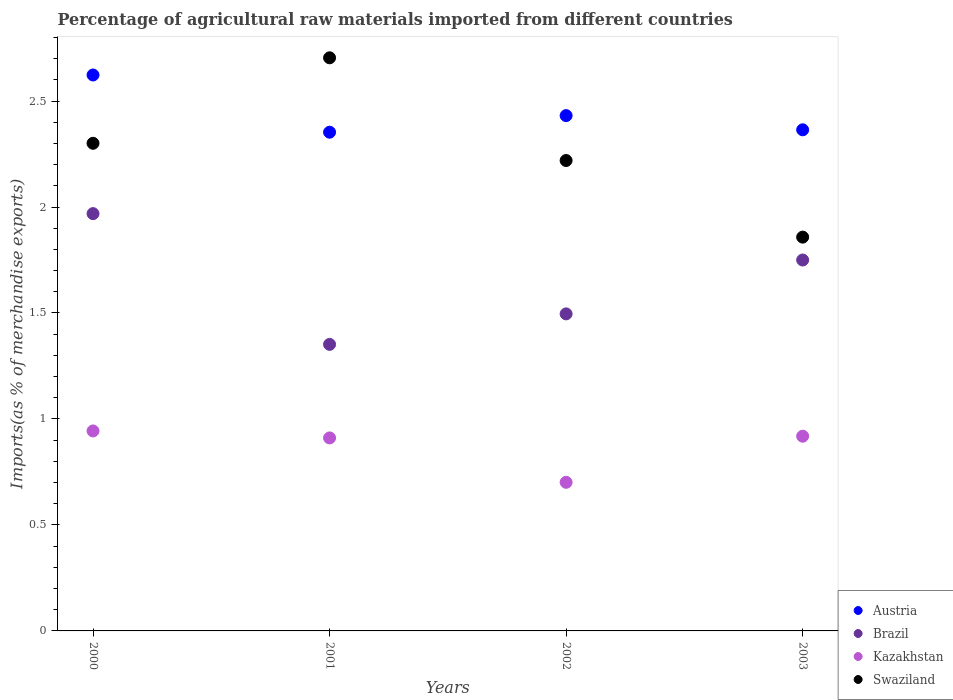Is the number of dotlines equal to the number of legend labels?
Give a very brief answer. Yes. What is the percentage of imports to different countries in Swaziland in 2001?
Keep it short and to the point. 2.7. Across all years, what is the maximum percentage of imports to different countries in Brazil?
Give a very brief answer. 1.97. Across all years, what is the minimum percentage of imports to different countries in Swaziland?
Offer a very short reply. 1.86. What is the total percentage of imports to different countries in Austria in the graph?
Offer a very short reply. 9.77. What is the difference between the percentage of imports to different countries in Kazakhstan in 2000 and that in 2001?
Your answer should be very brief. 0.03. What is the difference between the percentage of imports to different countries in Swaziland in 2003 and the percentage of imports to different countries in Brazil in 2001?
Ensure brevity in your answer.  0.51. What is the average percentage of imports to different countries in Brazil per year?
Keep it short and to the point. 1.64. In the year 2000, what is the difference between the percentage of imports to different countries in Kazakhstan and percentage of imports to different countries in Brazil?
Offer a very short reply. -1.03. What is the ratio of the percentage of imports to different countries in Brazil in 2002 to that in 2003?
Your response must be concise. 0.85. What is the difference between the highest and the second highest percentage of imports to different countries in Swaziland?
Keep it short and to the point. 0.4. What is the difference between the highest and the lowest percentage of imports to different countries in Brazil?
Keep it short and to the point. 0.62. Is it the case that in every year, the sum of the percentage of imports to different countries in Kazakhstan and percentage of imports to different countries in Brazil  is greater than the sum of percentage of imports to different countries in Austria and percentage of imports to different countries in Swaziland?
Provide a short and direct response. No. Does the percentage of imports to different countries in Austria monotonically increase over the years?
Ensure brevity in your answer.  No. Are the values on the major ticks of Y-axis written in scientific E-notation?
Your answer should be compact. No. Where does the legend appear in the graph?
Your answer should be compact. Bottom right. What is the title of the graph?
Keep it short and to the point. Percentage of agricultural raw materials imported from different countries. What is the label or title of the Y-axis?
Ensure brevity in your answer.  Imports(as % of merchandise exports). What is the Imports(as % of merchandise exports) of Austria in 2000?
Provide a succinct answer. 2.62. What is the Imports(as % of merchandise exports) in Brazil in 2000?
Provide a succinct answer. 1.97. What is the Imports(as % of merchandise exports) of Kazakhstan in 2000?
Provide a short and direct response. 0.94. What is the Imports(as % of merchandise exports) of Swaziland in 2000?
Your answer should be very brief. 2.3. What is the Imports(as % of merchandise exports) of Austria in 2001?
Keep it short and to the point. 2.35. What is the Imports(as % of merchandise exports) of Brazil in 2001?
Provide a short and direct response. 1.35. What is the Imports(as % of merchandise exports) of Kazakhstan in 2001?
Provide a succinct answer. 0.91. What is the Imports(as % of merchandise exports) in Swaziland in 2001?
Ensure brevity in your answer.  2.7. What is the Imports(as % of merchandise exports) in Austria in 2002?
Your answer should be compact. 2.43. What is the Imports(as % of merchandise exports) of Brazil in 2002?
Your answer should be very brief. 1.5. What is the Imports(as % of merchandise exports) in Kazakhstan in 2002?
Offer a terse response. 0.7. What is the Imports(as % of merchandise exports) in Swaziland in 2002?
Offer a very short reply. 2.22. What is the Imports(as % of merchandise exports) in Austria in 2003?
Give a very brief answer. 2.36. What is the Imports(as % of merchandise exports) of Brazil in 2003?
Your response must be concise. 1.75. What is the Imports(as % of merchandise exports) in Kazakhstan in 2003?
Offer a very short reply. 0.92. What is the Imports(as % of merchandise exports) in Swaziland in 2003?
Keep it short and to the point. 1.86. Across all years, what is the maximum Imports(as % of merchandise exports) of Austria?
Keep it short and to the point. 2.62. Across all years, what is the maximum Imports(as % of merchandise exports) of Brazil?
Your response must be concise. 1.97. Across all years, what is the maximum Imports(as % of merchandise exports) of Kazakhstan?
Offer a terse response. 0.94. Across all years, what is the maximum Imports(as % of merchandise exports) of Swaziland?
Ensure brevity in your answer.  2.7. Across all years, what is the minimum Imports(as % of merchandise exports) of Austria?
Offer a terse response. 2.35. Across all years, what is the minimum Imports(as % of merchandise exports) of Brazil?
Make the answer very short. 1.35. Across all years, what is the minimum Imports(as % of merchandise exports) of Kazakhstan?
Keep it short and to the point. 0.7. Across all years, what is the minimum Imports(as % of merchandise exports) of Swaziland?
Your answer should be compact. 1.86. What is the total Imports(as % of merchandise exports) of Austria in the graph?
Offer a terse response. 9.77. What is the total Imports(as % of merchandise exports) in Brazil in the graph?
Keep it short and to the point. 6.57. What is the total Imports(as % of merchandise exports) of Kazakhstan in the graph?
Offer a very short reply. 3.47. What is the total Imports(as % of merchandise exports) of Swaziland in the graph?
Keep it short and to the point. 9.08. What is the difference between the Imports(as % of merchandise exports) in Austria in 2000 and that in 2001?
Your response must be concise. 0.27. What is the difference between the Imports(as % of merchandise exports) in Brazil in 2000 and that in 2001?
Your answer should be very brief. 0.62. What is the difference between the Imports(as % of merchandise exports) in Kazakhstan in 2000 and that in 2001?
Provide a succinct answer. 0.03. What is the difference between the Imports(as % of merchandise exports) of Swaziland in 2000 and that in 2001?
Offer a terse response. -0.4. What is the difference between the Imports(as % of merchandise exports) in Austria in 2000 and that in 2002?
Offer a terse response. 0.19. What is the difference between the Imports(as % of merchandise exports) of Brazil in 2000 and that in 2002?
Your answer should be compact. 0.47. What is the difference between the Imports(as % of merchandise exports) of Kazakhstan in 2000 and that in 2002?
Offer a very short reply. 0.24. What is the difference between the Imports(as % of merchandise exports) in Swaziland in 2000 and that in 2002?
Your answer should be compact. 0.08. What is the difference between the Imports(as % of merchandise exports) of Austria in 2000 and that in 2003?
Your answer should be very brief. 0.26. What is the difference between the Imports(as % of merchandise exports) in Brazil in 2000 and that in 2003?
Your response must be concise. 0.22. What is the difference between the Imports(as % of merchandise exports) in Kazakhstan in 2000 and that in 2003?
Make the answer very short. 0.02. What is the difference between the Imports(as % of merchandise exports) in Swaziland in 2000 and that in 2003?
Ensure brevity in your answer.  0.44. What is the difference between the Imports(as % of merchandise exports) of Austria in 2001 and that in 2002?
Offer a terse response. -0.08. What is the difference between the Imports(as % of merchandise exports) of Brazil in 2001 and that in 2002?
Your answer should be very brief. -0.14. What is the difference between the Imports(as % of merchandise exports) of Kazakhstan in 2001 and that in 2002?
Provide a short and direct response. 0.21. What is the difference between the Imports(as % of merchandise exports) in Swaziland in 2001 and that in 2002?
Give a very brief answer. 0.48. What is the difference between the Imports(as % of merchandise exports) of Austria in 2001 and that in 2003?
Your response must be concise. -0.01. What is the difference between the Imports(as % of merchandise exports) in Brazil in 2001 and that in 2003?
Give a very brief answer. -0.4. What is the difference between the Imports(as % of merchandise exports) of Kazakhstan in 2001 and that in 2003?
Provide a short and direct response. -0.01. What is the difference between the Imports(as % of merchandise exports) of Swaziland in 2001 and that in 2003?
Your response must be concise. 0.85. What is the difference between the Imports(as % of merchandise exports) of Austria in 2002 and that in 2003?
Give a very brief answer. 0.07. What is the difference between the Imports(as % of merchandise exports) of Brazil in 2002 and that in 2003?
Provide a short and direct response. -0.25. What is the difference between the Imports(as % of merchandise exports) in Kazakhstan in 2002 and that in 2003?
Your response must be concise. -0.22. What is the difference between the Imports(as % of merchandise exports) of Swaziland in 2002 and that in 2003?
Ensure brevity in your answer.  0.36. What is the difference between the Imports(as % of merchandise exports) of Austria in 2000 and the Imports(as % of merchandise exports) of Brazil in 2001?
Keep it short and to the point. 1.27. What is the difference between the Imports(as % of merchandise exports) of Austria in 2000 and the Imports(as % of merchandise exports) of Kazakhstan in 2001?
Ensure brevity in your answer.  1.71. What is the difference between the Imports(as % of merchandise exports) in Austria in 2000 and the Imports(as % of merchandise exports) in Swaziland in 2001?
Ensure brevity in your answer.  -0.08. What is the difference between the Imports(as % of merchandise exports) of Brazil in 2000 and the Imports(as % of merchandise exports) of Kazakhstan in 2001?
Offer a very short reply. 1.06. What is the difference between the Imports(as % of merchandise exports) in Brazil in 2000 and the Imports(as % of merchandise exports) in Swaziland in 2001?
Provide a succinct answer. -0.74. What is the difference between the Imports(as % of merchandise exports) of Kazakhstan in 2000 and the Imports(as % of merchandise exports) of Swaziland in 2001?
Provide a succinct answer. -1.76. What is the difference between the Imports(as % of merchandise exports) in Austria in 2000 and the Imports(as % of merchandise exports) in Brazil in 2002?
Provide a succinct answer. 1.13. What is the difference between the Imports(as % of merchandise exports) in Austria in 2000 and the Imports(as % of merchandise exports) in Kazakhstan in 2002?
Make the answer very short. 1.92. What is the difference between the Imports(as % of merchandise exports) in Austria in 2000 and the Imports(as % of merchandise exports) in Swaziland in 2002?
Ensure brevity in your answer.  0.4. What is the difference between the Imports(as % of merchandise exports) in Brazil in 2000 and the Imports(as % of merchandise exports) in Kazakhstan in 2002?
Keep it short and to the point. 1.27. What is the difference between the Imports(as % of merchandise exports) in Brazil in 2000 and the Imports(as % of merchandise exports) in Swaziland in 2002?
Your response must be concise. -0.25. What is the difference between the Imports(as % of merchandise exports) in Kazakhstan in 2000 and the Imports(as % of merchandise exports) in Swaziland in 2002?
Make the answer very short. -1.28. What is the difference between the Imports(as % of merchandise exports) of Austria in 2000 and the Imports(as % of merchandise exports) of Brazil in 2003?
Your answer should be very brief. 0.87. What is the difference between the Imports(as % of merchandise exports) of Austria in 2000 and the Imports(as % of merchandise exports) of Kazakhstan in 2003?
Your answer should be very brief. 1.7. What is the difference between the Imports(as % of merchandise exports) in Austria in 2000 and the Imports(as % of merchandise exports) in Swaziland in 2003?
Provide a succinct answer. 0.77. What is the difference between the Imports(as % of merchandise exports) of Brazil in 2000 and the Imports(as % of merchandise exports) of Kazakhstan in 2003?
Your answer should be very brief. 1.05. What is the difference between the Imports(as % of merchandise exports) in Brazil in 2000 and the Imports(as % of merchandise exports) in Swaziland in 2003?
Ensure brevity in your answer.  0.11. What is the difference between the Imports(as % of merchandise exports) in Kazakhstan in 2000 and the Imports(as % of merchandise exports) in Swaziland in 2003?
Your answer should be compact. -0.91. What is the difference between the Imports(as % of merchandise exports) in Austria in 2001 and the Imports(as % of merchandise exports) in Brazil in 2002?
Your answer should be compact. 0.86. What is the difference between the Imports(as % of merchandise exports) of Austria in 2001 and the Imports(as % of merchandise exports) of Kazakhstan in 2002?
Provide a succinct answer. 1.65. What is the difference between the Imports(as % of merchandise exports) of Austria in 2001 and the Imports(as % of merchandise exports) of Swaziland in 2002?
Your response must be concise. 0.13. What is the difference between the Imports(as % of merchandise exports) of Brazil in 2001 and the Imports(as % of merchandise exports) of Kazakhstan in 2002?
Your answer should be compact. 0.65. What is the difference between the Imports(as % of merchandise exports) in Brazil in 2001 and the Imports(as % of merchandise exports) in Swaziland in 2002?
Ensure brevity in your answer.  -0.87. What is the difference between the Imports(as % of merchandise exports) of Kazakhstan in 2001 and the Imports(as % of merchandise exports) of Swaziland in 2002?
Ensure brevity in your answer.  -1.31. What is the difference between the Imports(as % of merchandise exports) of Austria in 2001 and the Imports(as % of merchandise exports) of Brazil in 2003?
Your answer should be very brief. 0.6. What is the difference between the Imports(as % of merchandise exports) in Austria in 2001 and the Imports(as % of merchandise exports) in Kazakhstan in 2003?
Give a very brief answer. 1.43. What is the difference between the Imports(as % of merchandise exports) of Austria in 2001 and the Imports(as % of merchandise exports) of Swaziland in 2003?
Provide a short and direct response. 0.49. What is the difference between the Imports(as % of merchandise exports) of Brazil in 2001 and the Imports(as % of merchandise exports) of Kazakhstan in 2003?
Make the answer very short. 0.43. What is the difference between the Imports(as % of merchandise exports) of Brazil in 2001 and the Imports(as % of merchandise exports) of Swaziland in 2003?
Ensure brevity in your answer.  -0.51. What is the difference between the Imports(as % of merchandise exports) of Kazakhstan in 2001 and the Imports(as % of merchandise exports) of Swaziland in 2003?
Your answer should be compact. -0.95. What is the difference between the Imports(as % of merchandise exports) in Austria in 2002 and the Imports(as % of merchandise exports) in Brazil in 2003?
Your answer should be very brief. 0.68. What is the difference between the Imports(as % of merchandise exports) in Austria in 2002 and the Imports(as % of merchandise exports) in Kazakhstan in 2003?
Offer a very short reply. 1.51. What is the difference between the Imports(as % of merchandise exports) of Austria in 2002 and the Imports(as % of merchandise exports) of Swaziland in 2003?
Ensure brevity in your answer.  0.57. What is the difference between the Imports(as % of merchandise exports) in Brazil in 2002 and the Imports(as % of merchandise exports) in Kazakhstan in 2003?
Offer a terse response. 0.58. What is the difference between the Imports(as % of merchandise exports) of Brazil in 2002 and the Imports(as % of merchandise exports) of Swaziland in 2003?
Offer a terse response. -0.36. What is the difference between the Imports(as % of merchandise exports) of Kazakhstan in 2002 and the Imports(as % of merchandise exports) of Swaziland in 2003?
Your answer should be compact. -1.16. What is the average Imports(as % of merchandise exports) of Austria per year?
Your answer should be compact. 2.44. What is the average Imports(as % of merchandise exports) of Brazil per year?
Provide a short and direct response. 1.64. What is the average Imports(as % of merchandise exports) of Kazakhstan per year?
Offer a very short reply. 0.87. What is the average Imports(as % of merchandise exports) of Swaziland per year?
Provide a succinct answer. 2.27. In the year 2000, what is the difference between the Imports(as % of merchandise exports) in Austria and Imports(as % of merchandise exports) in Brazil?
Provide a short and direct response. 0.65. In the year 2000, what is the difference between the Imports(as % of merchandise exports) of Austria and Imports(as % of merchandise exports) of Kazakhstan?
Give a very brief answer. 1.68. In the year 2000, what is the difference between the Imports(as % of merchandise exports) in Austria and Imports(as % of merchandise exports) in Swaziland?
Your response must be concise. 0.32. In the year 2000, what is the difference between the Imports(as % of merchandise exports) in Brazil and Imports(as % of merchandise exports) in Kazakhstan?
Offer a terse response. 1.03. In the year 2000, what is the difference between the Imports(as % of merchandise exports) in Brazil and Imports(as % of merchandise exports) in Swaziland?
Your response must be concise. -0.33. In the year 2000, what is the difference between the Imports(as % of merchandise exports) of Kazakhstan and Imports(as % of merchandise exports) of Swaziland?
Your answer should be compact. -1.36. In the year 2001, what is the difference between the Imports(as % of merchandise exports) in Austria and Imports(as % of merchandise exports) in Kazakhstan?
Give a very brief answer. 1.44. In the year 2001, what is the difference between the Imports(as % of merchandise exports) of Austria and Imports(as % of merchandise exports) of Swaziland?
Ensure brevity in your answer.  -0.35. In the year 2001, what is the difference between the Imports(as % of merchandise exports) in Brazil and Imports(as % of merchandise exports) in Kazakhstan?
Your answer should be very brief. 0.44. In the year 2001, what is the difference between the Imports(as % of merchandise exports) in Brazil and Imports(as % of merchandise exports) in Swaziland?
Make the answer very short. -1.35. In the year 2001, what is the difference between the Imports(as % of merchandise exports) in Kazakhstan and Imports(as % of merchandise exports) in Swaziland?
Provide a succinct answer. -1.79. In the year 2002, what is the difference between the Imports(as % of merchandise exports) of Austria and Imports(as % of merchandise exports) of Brazil?
Your response must be concise. 0.94. In the year 2002, what is the difference between the Imports(as % of merchandise exports) of Austria and Imports(as % of merchandise exports) of Kazakhstan?
Offer a very short reply. 1.73. In the year 2002, what is the difference between the Imports(as % of merchandise exports) of Austria and Imports(as % of merchandise exports) of Swaziland?
Provide a short and direct response. 0.21. In the year 2002, what is the difference between the Imports(as % of merchandise exports) in Brazil and Imports(as % of merchandise exports) in Kazakhstan?
Give a very brief answer. 0.79. In the year 2002, what is the difference between the Imports(as % of merchandise exports) in Brazil and Imports(as % of merchandise exports) in Swaziland?
Provide a short and direct response. -0.72. In the year 2002, what is the difference between the Imports(as % of merchandise exports) in Kazakhstan and Imports(as % of merchandise exports) in Swaziland?
Make the answer very short. -1.52. In the year 2003, what is the difference between the Imports(as % of merchandise exports) of Austria and Imports(as % of merchandise exports) of Brazil?
Your answer should be very brief. 0.61. In the year 2003, what is the difference between the Imports(as % of merchandise exports) in Austria and Imports(as % of merchandise exports) in Kazakhstan?
Your answer should be very brief. 1.45. In the year 2003, what is the difference between the Imports(as % of merchandise exports) in Austria and Imports(as % of merchandise exports) in Swaziland?
Keep it short and to the point. 0.51. In the year 2003, what is the difference between the Imports(as % of merchandise exports) in Brazil and Imports(as % of merchandise exports) in Kazakhstan?
Offer a very short reply. 0.83. In the year 2003, what is the difference between the Imports(as % of merchandise exports) of Brazil and Imports(as % of merchandise exports) of Swaziland?
Offer a very short reply. -0.11. In the year 2003, what is the difference between the Imports(as % of merchandise exports) in Kazakhstan and Imports(as % of merchandise exports) in Swaziland?
Give a very brief answer. -0.94. What is the ratio of the Imports(as % of merchandise exports) of Austria in 2000 to that in 2001?
Your answer should be compact. 1.11. What is the ratio of the Imports(as % of merchandise exports) of Brazil in 2000 to that in 2001?
Ensure brevity in your answer.  1.46. What is the ratio of the Imports(as % of merchandise exports) of Kazakhstan in 2000 to that in 2001?
Your response must be concise. 1.04. What is the ratio of the Imports(as % of merchandise exports) of Swaziland in 2000 to that in 2001?
Provide a short and direct response. 0.85. What is the ratio of the Imports(as % of merchandise exports) of Austria in 2000 to that in 2002?
Provide a succinct answer. 1.08. What is the ratio of the Imports(as % of merchandise exports) of Brazil in 2000 to that in 2002?
Your response must be concise. 1.32. What is the ratio of the Imports(as % of merchandise exports) of Kazakhstan in 2000 to that in 2002?
Your answer should be very brief. 1.35. What is the ratio of the Imports(as % of merchandise exports) in Swaziland in 2000 to that in 2002?
Offer a terse response. 1.04. What is the ratio of the Imports(as % of merchandise exports) of Austria in 2000 to that in 2003?
Offer a terse response. 1.11. What is the ratio of the Imports(as % of merchandise exports) in Brazil in 2000 to that in 2003?
Ensure brevity in your answer.  1.12. What is the ratio of the Imports(as % of merchandise exports) of Kazakhstan in 2000 to that in 2003?
Your response must be concise. 1.03. What is the ratio of the Imports(as % of merchandise exports) in Swaziland in 2000 to that in 2003?
Keep it short and to the point. 1.24. What is the ratio of the Imports(as % of merchandise exports) of Austria in 2001 to that in 2002?
Provide a succinct answer. 0.97. What is the ratio of the Imports(as % of merchandise exports) of Brazil in 2001 to that in 2002?
Offer a terse response. 0.9. What is the ratio of the Imports(as % of merchandise exports) in Kazakhstan in 2001 to that in 2002?
Make the answer very short. 1.3. What is the ratio of the Imports(as % of merchandise exports) in Swaziland in 2001 to that in 2002?
Keep it short and to the point. 1.22. What is the ratio of the Imports(as % of merchandise exports) in Brazil in 2001 to that in 2003?
Keep it short and to the point. 0.77. What is the ratio of the Imports(as % of merchandise exports) of Swaziland in 2001 to that in 2003?
Make the answer very short. 1.46. What is the ratio of the Imports(as % of merchandise exports) of Austria in 2002 to that in 2003?
Offer a very short reply. 1.03. What is the ratio of the Imports(as % of merchandise exports) in Brazil in 2002 to that in 2003?
Ensure brevity in your answer.  0.85. What is the ratio of the Imports(as % of merchandise exports) in Kazakhstan in 2002 to that in 2003?
Your answer should be compact. 0.76. What is the ratio of the Imports(as % of merchandise exports) of Swaziland in 2002 to that in 2003?
Make the answer very short. 1.19. What is the difference between the highest and the second highest Imports(as % of merchandise exports) of Austria?
Provide a short and direct response. 0.19. What is the difference between the highest and the second highest Imports(as % of merchandise exports) of Brazil?
Ensure brevity in your answer.  0.22. What is the difference between the highest and the second highest Imports(as % of merchandise exports) in Kazakhstan?
Your answer should be very brief. 0.02. What is the difference between the highest and the second highest Imports(as % of merchandise exports) of Swaziland?
Make the answer very short. 0.4. What is the difference between the highest and the lowest Imports(as % of merchandise exports) in Austria?
Offer a very short reply. 0.27. What is the difference between the highest and the lowest Imports(as % of merchandise exports) in Brazil?
Your answer should be very brief. 0.62. What is the difference between the highest and the lowest Imports(as % of merchandise exports) of Kazakhstan?
Ensure brevity in your answer.  0.24. What is the difference between the highest and the lowest Imports(as % of merchandise exports) of Swaziland?
Offer a very short reply. 0.85. 